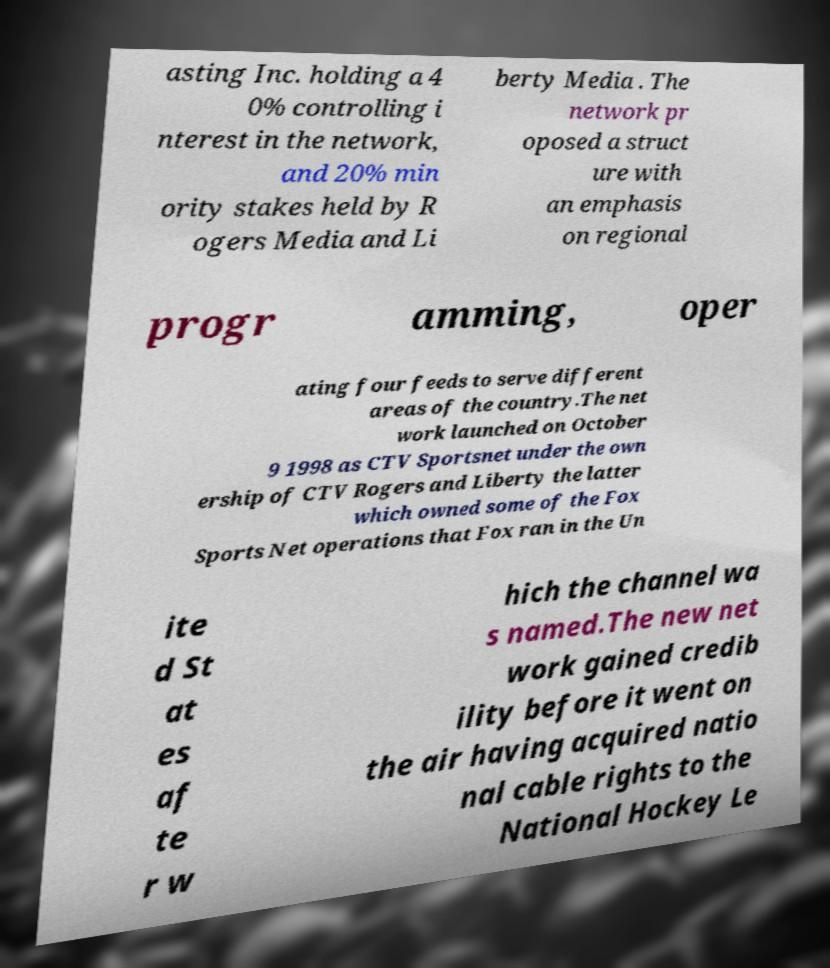What messages or text are displayed in this image? I need them in a readable, typed format. asting Inc. holding a 4 0% controlling i nterest in the network, and 20% min ority stakes held by R ogers Media and Li berty Media . The network pr oposed a struct ure with an emphasis on regional progr amming, oper ating four feeds to serve different areas of the country.The net work launched on October 9 1998 as CTV Sportsnet under the own ership of CTV Rogers and Liberty the latter which owned some of the Fox Sports Net operations that Fox ran in the Un ite d St at es af te r w hich the channel wa s named.The new net work gained credib ility before it went on the air having acquired natio nal cable rights to the National Hockey Le 